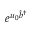Convert formula to latex. <formula><loc_0><loc_0><loc_500><loc_500>e ^ { u _ { 0 } \hat { b } ^ { \dagger } }</formula> 